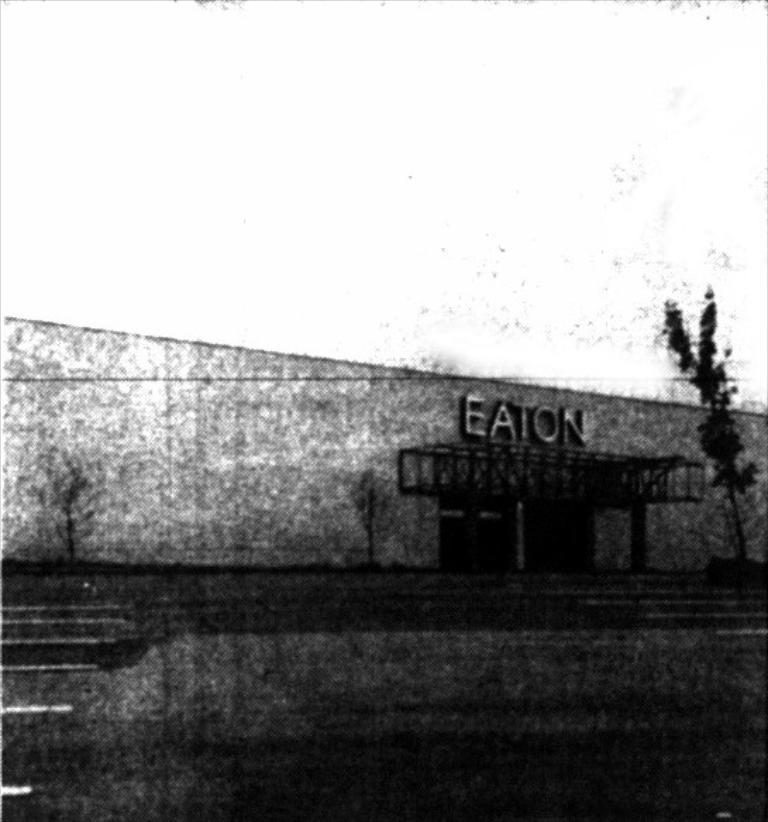<image>
Give a short and clear explanation of the subsequent image. a building that has the name Eaton on it 